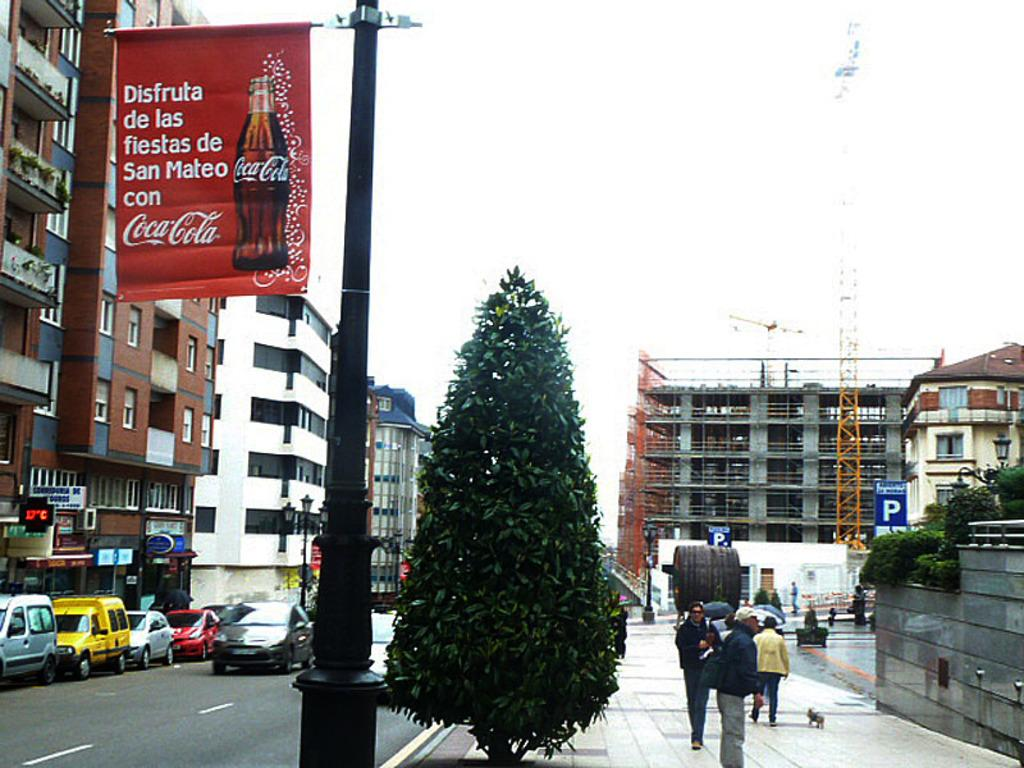<image>
Describe the image concisely. a Coca Cola ad on a light that is outside in daytime 